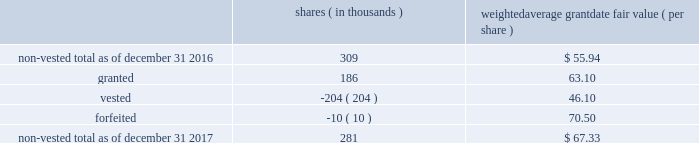The table below summarizes activity of rsus with performance conditions for the year ended december 31 , shares ( in thousands ) weighted average grant date fair value ( per share ) .
As of december 31 , 2017 , $ 6 million of total unrecognized compensation cost related to the nonvested rsus , with and without performance conditions , is expected to be recognized over the weighted-average remaining life of 1.5 years .
The total fair value of rsus , with and without performance conditions , vested was $ 16 million , $ 14 million and $ 12 million for the years ended december 31 , 2017 , 2016 and 2015 , respectively .
If dividends are paid with respect to shares of the company 2019s common stock before the rsus are distributed , the company credits a liability for the value of the dividends that would have been paid if the rsus were shares of company common stock .
When the rsus are distributed , the company pays the participant a lump sum cash payment equal to the value of the dividend equivalents accrued .
The company accrued dividend equivalents totaling less than $ 1 million , $ 1 million and $ 1 million to accumulated deficit in the accompanying consolidated statements of changes in stockholders 2019 equity for the years ended december 31 , 2017 , 2016 and 2015 , respectively .
Employee stock purchase plan the company maintains a nonqualified employee stock purchase plan ( the 201cespp 201d ) through which employee participants may use payroll deductions to acquire company common stock at the lesser of 90% ( 90 % ) of the fair market value of the common stock at either the beginning or the end of a three-month purchase period .
On february 15 , 2017 , the board adopted the american water works company , inc .
And its designated subsidiaries 2017 nonqualified employee stock purchase plan , which was approved by stockholders on may 12 , 2017 and took effect on august 5 , 2017 .
The prior plan was terminated as to new purchases of company stock effective august 31 , 2017 .
As of december 31 , 2017 , there were 2.0 million shares of common stock reserved for issuance under the espp .
The espp is considered compensatory .
During the years ended december 31 , 2017 , 2016 and 2015 , the company issued 93 thousand , 93 thousand and 98 thousand shares , respectively , under the espp. .
By how much did non-vested rsu's decrease from 2016 to 2017? 
Computations: ((281 - 309) / 309)
Answer: -0.09061. The table below summarizes activity of rsus with performance conditions for the year ended december 31 , shares ( in thousands ) weighted average grant date fair value ( per share ) .
As of december 31 , 2017 , $ 6 million of total unrecognized compensation cost related to the nonvested rsus , with and without performance conditions , is expected to be recognized over the weighted-average remaining life of 1.5 years .
The total fair value of rsus , with and without performance conditions , vested was $ 16 million , $ 14 million and $ 12 million for the years ended december 31 , 2017 , 2016 and 2015 , respectively .
If dividends are paid with respect to shares of the company 2019s common stock before the rsus are distributed , the company credits a liability for the value of the dividends that would have been paid if the rsus were shares of company common stock .
When the rsus are distributed , the company pays the participant a lump sum cash payment equal to the value of the dividend equivalents accrued .
The company accrued dividend equivalents totaling less than $ 1 million , $ 1 million and $ 1 million to accumulated deficit in the accompanying consolidated statements of changes in stockholders 2019 equity for the years ended december 31 , 2017 , 2016 and 2015 , respectively .
Employee stock purchase plan the company maintains a nonqualified employee stock purchase plan ( the 201cespp 201d ) through which employee participants may use payroll deductions to acquire company common stock at the lesser of 90% ( 90 % ) of the fair market value of the common stock at either the beginning or the end of a three-month purchase period .
On february 15 , 2017 , the board adopted the american water works company , inc .
And its designated subsidiaries 2017 nonqualified employee stock purchase plan , which was approved by stockholders on may 12 , 2017 and took effect on august 5 , 2017 .
The prior plan was terminated as to new purchases of company stock effective august 31 , 2017 .
As of december 31 , 2017 , there were 2.0 million shares of common stock reserved for issuance under the espp .
The espp is considered compensatory .
During the years ended december 31 , 2017 , 2016 and 2015 , the company issued 93 thousand , 93 thousand and 98 thousand shares , respectively , under the espp. .
Based on the weighted average grant date fair value ( per share ) , what was the total granted rsu cost during 2017? 
Computations: ((186 * 1000) * 63.10)
Answer: 11736600.0. 